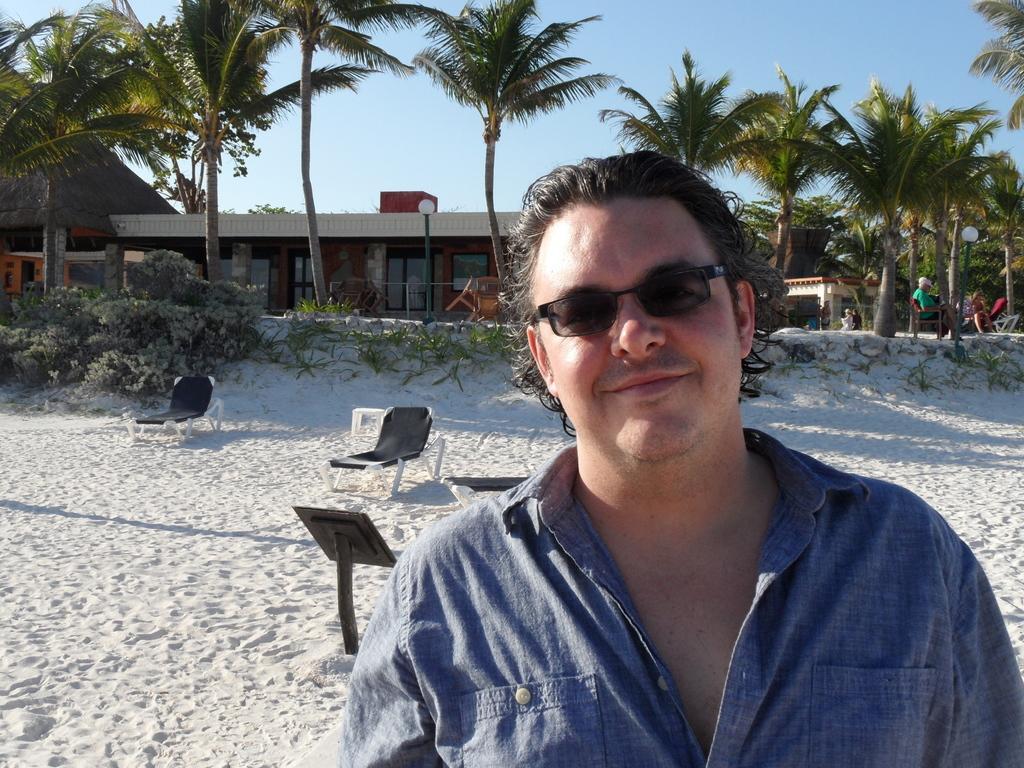Can you describe this image briefly? Here, we can see a man standing and he is wearing specs, there are some chairs and we can see some plants and trees, there is a house, at the top there is a blue sky. 